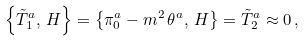Convert formula to latex. <formula><loc_0><loc_0><loc_500><loc_500>\left \{ \tilde { T } _ { 1 } ^ { a } , \, H \right \} = \left \{ \pi _ { 0 } ^ { a } - m ^ { 2 } \, \theta ^ { a } , \, H \right \} = \tilde { T } _ { 2 } ^ { a } \approx 0 \, ,</formula> 